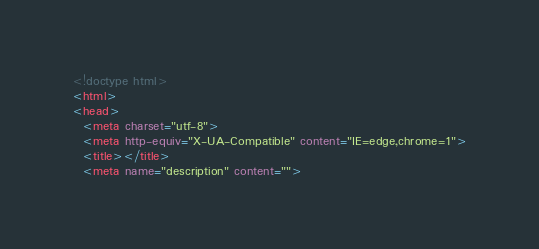<code> <loc_0><loc_0><loc_500><loc_500><_HTML_><!doctype html>
<html>
<head>
  <meta charset="utf-8">
  <meta http-equiv="X-UA-Compatible" content="IE=edge,chrome=1">
  <title></title>
  <meta name="description" content=""></code> 